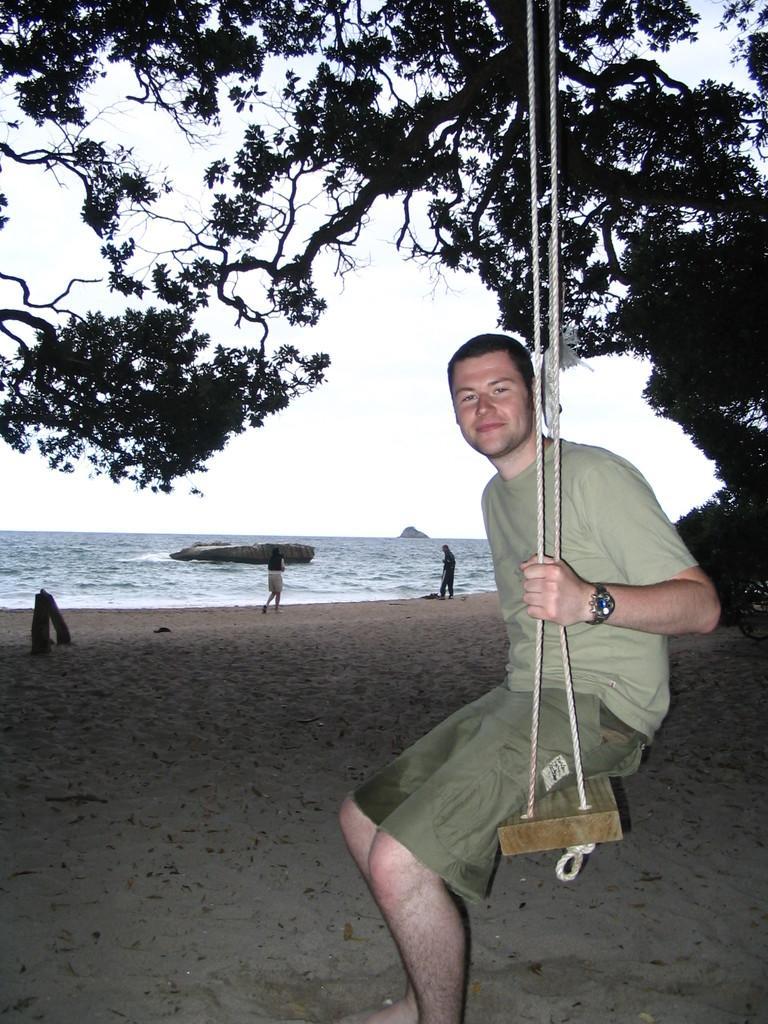Could you give a brief overview of what you see in this image? In this picture we can see few people, on the right side of the image we can see a man, he is sitting on the swing, in the background we can find few trees and water. 